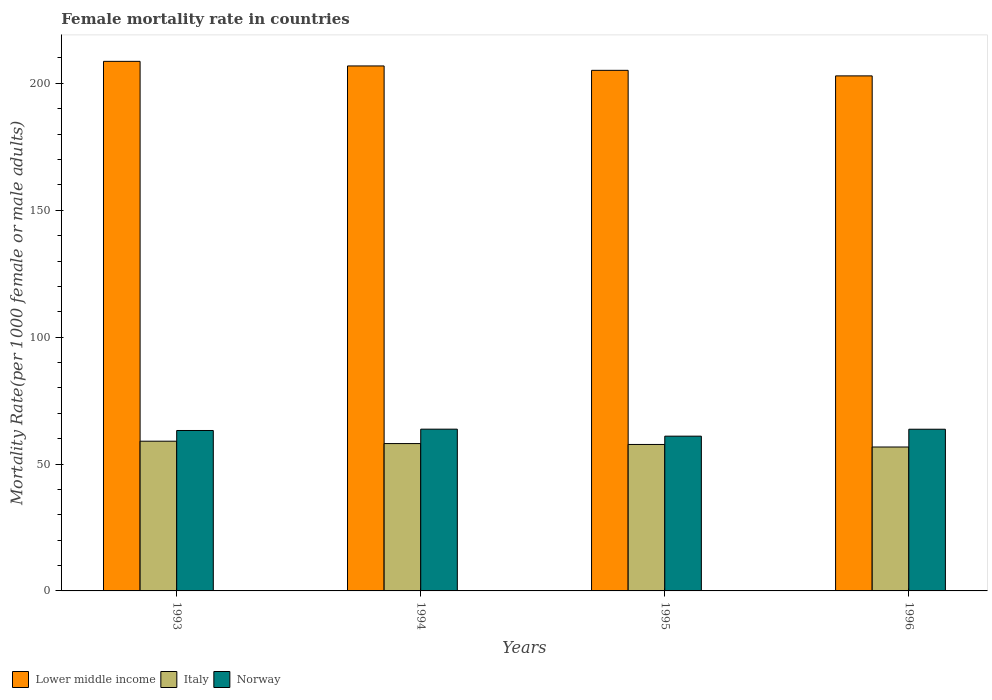How many different coloured bars are there?
Your response must be concise. 3. How many bars are there on the 3rd tick from the left?
Make the answer very short. 3. What is the label of the 1st group of bars from the left?
Ensure brevity in your answer.  1993. What is the female mortality rate in Lower middle income in 1996?
Provide a succinct answer. 202.95. Across all years, what is the maximum female mortality rate in Lower middle income?
Provide a succinct answer. 208.67. Across all years, what is the minimum female mortality rate in Italy?
Provide a succinct answer. 56.71. In which year was the female mortality rate in Norway minimum?
Your response must be concise. 1995. What is the total female mortality rate in Lower middle income in the graph?
Your response must be concise. 823.62. What is the difference between the female mortality rate in Norway in 1993 and that in 1995?
Provide a succinct answer. 2.24. What is the difference between the female mortality rate in Norway in 1996 and the female mortality rate in Lower middle income in 1995?
Make the answer very short. -141.42. What is the average female mortality rate in Lower middle income per year?
Offer a very short reply. 205.91. In the year 1994, what is the difference between the female mortality rate in Lower middle income and female mortality rate in Italy?
Offer a terse response. 148.8. In how many years, is the female mortality rate in Lower middle income greater than 20?
Offer a very short reply. 4. What is the ratio of the female mortality rate in Italy in 1993 to that in 1994?
Make the answer very short. 1.02. Is the female mortality rate in Italy in 1993 less than that in 1994?
Ensure brevity in your answer.  No. What is the difference between the highest and the second highest female mortality rate in Lower middle income?
Ensure brevity in your answer.  1.81. What is the difference between the highest and the lowest female mortality rate in Norway?
Your answer should be compact. 2.76. What does the 3rd bar from the left in 1995 represents?
Your response must be concise. Norway. What does the 3rd bar from the right in 1994 represents?
Ensure brevity in your answer.  Lower middle income. How many bars are there?
Your answer should be compact. 12. How many years are there in the graph?
Give a very brief answer. 4. Are the values on the major ticks of Y-axis written in scientific E-notation?
Your answer should be very brief. No. Does the graph contain any zero values?
Provide a succinct answer. No. Where does the legend appear in the graph?
Your response must be concise. Bottom left. How are the legend labels stacked?
Keep it short and to the point. Horizontal. What is the title of the graph?
Your response must be concise. Female mortality rate in countries. What is the label or title of the Y-axis?
Ensure brevity in your answer.  Mortality Rate(per 1000 female or male adults). What is the Mortality Rate(per 1000 female or male adults) in Lower middle income in 1993?
Your answer should be very brief. 208.67. What is the Mortality Rate(per 1000 female or male adults) in Italy in 1993?
Your answer should be compact. 59. What is the Mortality Rate(per 1000 female or male adults) of Norway in 1993?
Make the answer very short. 63.22. What is the Mortality Rate(per 1000 female or male adults) of Lower middle income in 1994?
Your answer should be very brief. 206.86. What is the Mortality Rate(per 1000 female or male adults) in Italy in 1994?
Keep it short and to the point. 58.06. What is the Mortality Rate(per 1000 female or male adults) in Norway in 1994?
Offer a very short reply. 63.74. What is the Mortality Rate(per 1000 female or male adults) of Lower middle income in 1995?
Offer a very short reply. 205.13. What is the Mortality Rate(per 1000 female or male adults) in Italy in 1995?
Provide a short and direct response. 57.71. What is the Mortality Rate(per 1000 female or male adults) of Norway in 1995?
Provide a short and direct response. 60.98. What is the Mortality Rate(per 1000 female or male adults) of Lower middle income in 1996?
Offer a terse response. 202.95. What is the Mortality Rate(per 1000 female or male adults) in Italy in 1996?
Make the answer very short. 56.71. What is the Mortality Rate(per 1000 female or male adults) in Norway in 1996?
Give a very brief answer. 63.72. Across all years, what is the maximum Mortality Rate(per 1000 female or male adults) of Lower middle income?
Ensure brevity in your answer.  208.67. Across all years, what is the maximum Mortality Rate(per 1000 female or male adults) of Norway?
Make the answer very short. 63.74. Across all years, what is the minimum Mortality Rate(per 1000 female or male adults) in Lower middle income?
Keep it short and to the point. 202.95. Across all years, what is the minimum Mortality Rate(per 1000 female or male adults) in Italy?
Provide a succinct answer. 56.71. Across all years, what is the minimum Mortality Rate(per 1000 female or male adults) in Norway?
Offer a very short reply. 60.98. What is the total Mortality Rate(per 1000 female or male adults) in Lower middle income in the graph?
Your answer should be very brief. 823.62. What is the total Mortality Rate(per 1000 female or male adults) of Italy in the graph?
Your response must be concise. 231.48. What is the total Mortality Rate(per 1000 female or male adults) of Norway in the graph?
Provide a succinct answer. 251.66. What is the difference between the Mortality Rate(per 1000 female or male adults) of Lower middle income in 1993 and that in 1994?
Keep it short and to the point. 1.81. What is the difference between the Mortality Rate(per 1000 female or male adults) of Italy in 1993 and that in 1994?
Your answer should be very brief. 0.94. What is the difference between the Mortality Rate(per 1000 female or male adults) in Norway in 1993 and that in 1994?
Offer a terse response. -0.52. What is the difference between the Mortality Rate(per 1000 female or male adults) in Lower middle income in 1993 and that in 1995?
Ensure brevity in your answer.  3.54. What is the difference between the Mortality Rate(per 1000 female or male adults) in Italy in 1993 and that in 1995?
Your answer should be compact. 1.29. What is the difference between the Mortality Rate(per 1000 female or male adults) of Norway in 1993 and that in 1995?
Ensure brevity in your answer.  2.24. What is the difference between the Mortality Rate(per 1000 female or male adults) in Lower middle income in 1993 and that in 1996?
Ensure brevity in your answer.  5.72. What is the difference between the Mortality Rate(per 1000 female or male adults) in Italy in 1993 and that in 1996?
Offer a very short reply. 2.29. What is the difference between the Mortality Rate(per 1000 female or male adults) of Norway in 1993 and that in 1996?
Your answer should be compact. -0.5. What is the difference between the Mortality Rate(per 1000 female or male adults) of Lower middle income in 1994 and that in 1995?
Offer a very short reply. 1.73. What is the difference between the Mortality Rate(per 1000 female or male adults) in Italy in 1994 and that in 1995?
Your answer should be very brief. 0.35. What is the difference between the Mortality Rate(per 1000 female or male adults) in Norway in 1994 and that in 1995?
Make the answer very short. 2.76. What is the difference between the Mortality Rate(per 1000 female or male adults) in Lower middle income in 1994 and that in 1996?
Offer a terse response. 3.91. What is the difference between the Mortality Rate(per 1000 female or male adults) in Italy in 1994 and that in 1996?
Your answer should be compact. 1.35. What is the difference between the Mortality Rate(per 1000 female or male adults) in Norway in 1994 and that in 1996?
Give a very brief answer. 0.02. What is the difference between the Mortality Rate(per 1000 female or male adults) of Lower middle income in 1995 and that in 1996?
Give a very brief answer. 2.19. What is the difference between the Mortality Rate(per 1000 female or male adults) in Italy in 1995 and that in 1996?
Keep it short and to the point. 1. What is the difference between the Mortality Rate(per 1000 female or male adults) of Norway in 1995 and that in 1996?
Your answer should be compact. -2.73. What is the difference between the Mortality Rate(per 1000 female or male adults) of Lower middle income in 1993 and the Mortality Rate(per 1000 female or male adults) of Italy in 1994?
Keep it short and to the point. 150.61. What is the difference between the Mortality Rate(per 1000 female or male adults) of Lower middle income in 1993 and the Mortality Rate(per 1000 female or male adults) of Norway in 1994?
Provide a succinct answer. 144.93. What is the difference between the Mortality Rate(per 1000 female or male adults) in Italy in 1993 and the Mortality Rate(per 1000 female or male adults) in Norway in 1994?
Keep it short and to the point. -4.74. What is the difference between the Mortality Rate(per 1000 female or male adults) of Lower middle income in 1993 and the Mortality Rate(per 1000 female or male adults) of Italy in 1995?
Provide a succinct answer. 150.97. What is the difference between the Mortality Rate(per 1000 female or male adults) in Lower middle income in 1993 and the Mortality Rate(per 1000 female or male adults) in Norway in 1995?
Offer a terse response. 147.69. What is the difference between the Mortality Rate(per 1000 female or male adults) in Italy in 1993 and the Mortality Rate(per 1000 female or male adults) in Norway in 1995?
Offer a very short reply. -1.98. What is the difference between the Mortality Rate(per 1000 female or male adults) of Lower middle income in 1993 and the Mortality Rate(per 1000 female or male adults) of Italy in 1996?
Your answer should be compact. 151.96. What is the difference between the Mortality Rate(per 1000 female or male adults) in Lower middle income in 1993 and the Mortality Rate(per 1000 female or male adults) in Norway in 1996?
Your answer should be compact. 144.96. What is the difference between the Mortality Rate(per 1000 female or male adults) of Italy in 1993 and the Mortality Rate(per 1000 female or male adults) of Norway in 1996?
Make the answer very short. -4.72. What is the difference between the Mortality Rate(per 1000 female or male adults) of Lower middle income in 1994 and the Mortality Rate(per 1000 female or male adults) of Italy in 1995?
Give a very brief answer. 149.15. What is the difference between the Mortality Rate(per 1000 female or male adults) of Lower middle income in 1994 and the Mortality Rate(per 1000 female or male adults) of Norway in 1995?
Provide a short and direct response. 145.88. What is the difference between the Mortality Rate(per 1000 female or male adults) of Italy in 1994 and the Mortality Rate(per 1000 female or male adults) of Norway in 1995?
Your response must be concise. -2.92. What is the difference between the Mortality Rate(per 1000 female or male adults) of Lower middle income in 1994 and the Mortality Rate(per 1000 female or male adults) of Italy in 1996?
Your answer should be compact. 150.15. What is the difference between the Mortality Rate(per 1000 female or male adults) in Lower middle income in 1994 and the Mortality Rate(per 1000 female or male adults) in Norway in 1996?
Make the answer very short. 143.15. What is the difference between the Mortality Rate(per 1000 female or male adults) in Italy in 1994 and the Mortality Rate(per 1000 female or male adults) in Norway in 1996?
Give a very brief answer. -5.66. What is the difference between the Mortality Rate(per 1000 female or male adults) in Lower middle income in 1995 and the Mortality Rate(per 1000 female or male adults) in Italy in 1996?
Offer a very short reply. 148.42. What is the difference between the Mortality Rate(per 1000 female or male adults) of Lower middle income in 1995 and the Mortality Rate(per 1000 female or male adults) of Norway in 1996?
Provide a succinct answer. 141.42. What is the difference between the Mortality Rate(per 1000 female or male adults) in Italy in 1995 and the Mortality Rate(per 1000 female or male adults) in Norway in 1996?
Ensure brevity in your answer.  -6.01. What is the average Mortality Rate(per 1000 female or male adults) in Lower middle income per year?
Keep it short and to the point. 205.91. What is the average Mortality Rate(per 1000 female or male adults) of Italy per year?
Provide a succinct answer. 57.87. What is the average Mortality Rate(per 1000 female or male adults) in Norway per year?
Ensure brevity in your answer.  62.92. In the year 1993, what is the difference between the Mortality Rate(per 1000 female or male adults) of Lower middle income and Mortality Rate(per 1000 female or male adults) of Italy?
Give a very brief answer. 149.67. In the year 1993, what is the difference between the Mortality Rate(per 1000 female or male adults) of Lower middle income and Mortality Rate(per 1000 female or male adults) of Norway?
Ensure brevity in your answer.  145.46. In the year 1993, what is the difference between the Mortality Rate(per 1000 female or male adults) of Italy and Mortality Rate(per 1000 female or male adults) of Norway?
Offer a very short reply. -4.22. In the year 1994, what is the difference between the Mortality Rate(per 1000 female or male adults) in Lower middle income and Mortality Rate(per 1000 female or male adults) in Italy?
Ensure brevity in your answer.  148.8. In the year 1994, what is the difference between the Mortality Rate(per 1000 female or male adults) in Lower middle income and Mortality Rate(per 1000 female or male adults) in Norway?
Make the answer very short. 143.12. In the year 1994, what is the difference between the Mortality Rate(per 1000 female or male adults) in Italy and Mortality Rate(per 1000 female or male adults) in Norway?
Offer a terse response. -5.68. In the year 1995, what is the difference between the Mortality Rate(per 1000 female or male adults) of Lower middle income and Mortality Rate(per 1000 female or male adults) of Italy?
Your answer should be compact. 147.43. In the year 1995, what is the difference between the Mortality Rate(per 1000 female or male adults) in Lower middle income and Mortality Rate(per 1000 female or male adults) in Norway?
Provide a succinct answer. 144.15. In the year 1995, what is the difference between the Mortality Rate(per 1000 female or male adults) in Italy and Mortality Rate(per 1000 female or male adults) in Norway?
Your answer should be compact. -3.27. In the year 1996, what is the difference between the Mortality Rate(per 1000 female or male adults) in Lower middle income and Mortality Rate(per 1000 female or male adults) in Italy?
Ensure brevity in your answer.  146.24. In the year 1996, what is the difference between the Mortality Rate(per 1000 female or male adults) of Lower middle income and Mortality Rate(per 1000 female or male adults) of Norway?
Provide a short and direct response. 139.23. In the year 1996, what is the difference between the Mortality Rate(per 1000 female or male adults) of Italy and Mortality Rate(per 1000 female or male adults) of Norway?
Offer a terse response. -7.01. What is the ratio of the Mortality Rate(per 1000 female or male adults) of Lower middle income in 1993 to that in 1994?
Your answer should be very brief. 1.01. What is the ratio of the Mortality Rate(per 1000 female or male adults) in Italy in 1993 to that in 1994?
Your answer should be very brief. 1.02. What is the ratio of the Mortality Rate(per 1000 female or male adults) of Norway in 1993 to that in 1994?
Provide a short and direct response. 0.99. What is the ratio of the Mortality Rate(per 1000 female or male adults) of Lower middle income in 1993 to that in 1995?
Provide a short and direct response. 1.02. What is the ratio of the Mortality Rate(per 1000 female or male adults) of Italy in 1993 to that in 1995?
Provide a short and direct response. 1.02. What is the ratio of the Mortality Rate(per 1000 female or male adults) in Norway in 1993 to that in 1995?
Offer a terse response. 1.04. What is the ratio of the Mortality Rate(per 1000 female or male adults) of Lower middle income in 1993 to that in 1996?
Offer a very short reply. 1.03. What is the ratio of the Mortality Rate(per 1000 female or male adults) of Italy in 1993 to that in 1996?
Your response must be concise. 1.04. What is the ratio of the Mortality Rate(per 1000 female or male adults) in Lower middle income in 1994 to that in 1995?
Ensure brevity in your answer.  1.01. What is the ratio of the Mortality Rate(per 1000 female or male adults) of Norway in 1994 to that in 1995?
Your response must be concise. 1.05. What is the ratio of the Mortality Rate(per 1000 female or male adults) in Lower middle income in 1994 to that in 1996?
Keep it short and to the point. 1.02. What is the ratio of the Mortality Rate(per 1000 female or male adults) of Italy in 1994 to that in 1996?
Keep it short and to the point. 1.02. What is the ratio of the Mortality Rate(per 1000 female or male adults) in Norway in 1994 to that in 1996?
Offer a terse response. 1. What is the ratio of the Mortality Rate(per 1000 female or male adults) of Lower middle income in 1995 to that in 1996?
Provide a succinct answer. 1.01. What is the ratio of the Mortality Rate(per 1000 female or male adults) in Italy in 1995 to that in 1996?
Keep it short and to the point. 1.02. What is the ratio of the Mortality Rate(per 1000 female or male adults) of Norway in 1995 to that in 1996?
Offer a very short reply. 0.96. What is the difference between the highest and the second highest Mortality Rate(per 1000 female or male adults) of Lower middle income?
Your answer should be compact. 1.81. What is the difference between the highest and the second highest Mortality Rate(per 1000 female or male adults) of Italy?
Give a very brief answer. 0.94. What is the difference between the highest and the second highest Mortality Rate(per 1000 female or male adults) in Norway?
Give a very brief answer. 0.02. What is the difference between the highest and the lowest Mortality Rate(per 1000 female or male adults) of Lower middle income?
Offer a very short reply. 5.72. What is the difference between the highest and the lowest Mortality Rate(per 1000 female or male adults) of Italy?
Your answer should be compact. 2.29. What is the difference between the highest and the lowest Mortality Rate(per 1000 female or male adults) of Norway?
Make the answer very short. 2.76. 